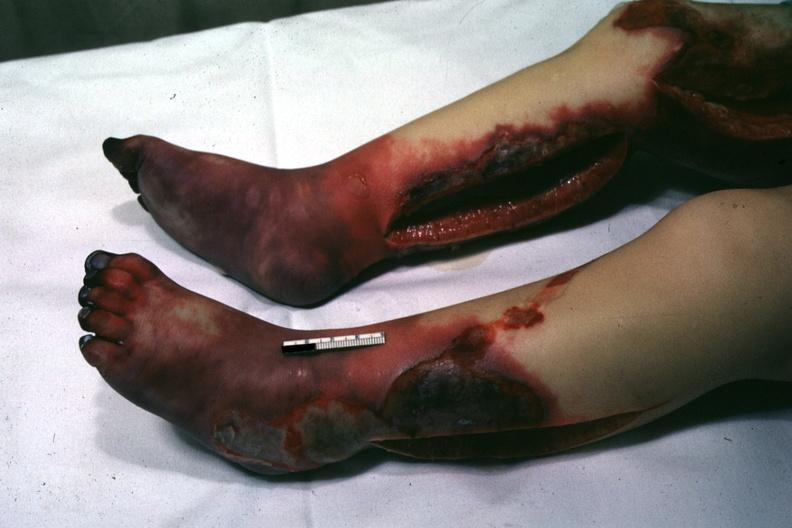what is present?
Answer the question using a single word or phrase. Acrocyanosis 